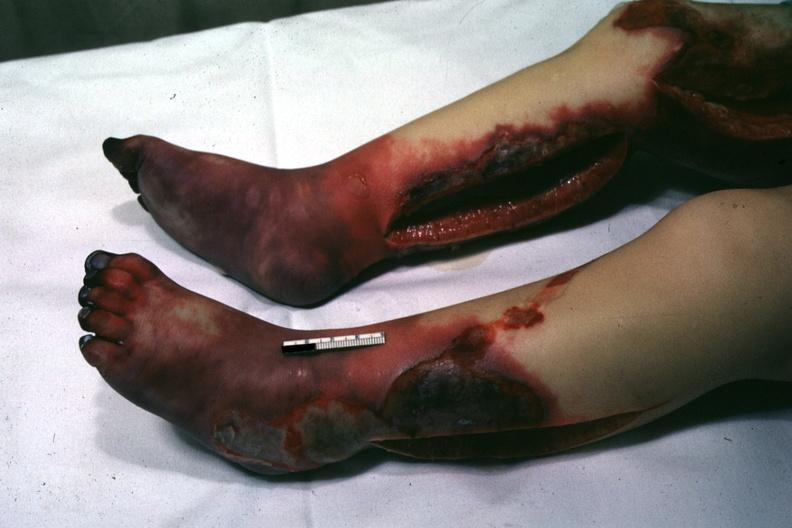what is present?
Answer the question using a single word or phrase. Acrocyanosis 